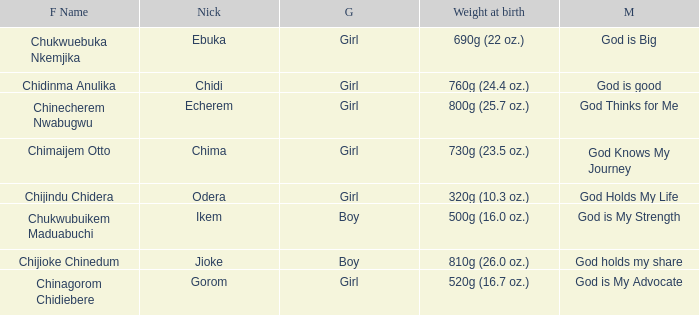Help me parse the entirety of this table. {'header': ['F Name', 'Nick', 'G', 'Weight at birth', 'M'], 'rows': [['Chukwuebuka Nkemjika', 'Ebuka', 'Girl', '690g (22 oz.)', 'God is Big'], ['Chidinma Anulika', 'Chidi', 'Girl', '760g (24.4 oz.)', 'God is good'], ['Chinecherem Nwabugwu', 'Echerem', 'Girl', '800g (25.7 oz.)', 'God Thinks for Me'], ['Chimaijem Otto', 'Chima', 'Girl', '730g (23.5 oz.)', 'God Knows My Journey'], ['Chijindu Chidera', 'Odera', 'Girl', '320g (10.3 oz.)', 'God Holds My Life'], ['Chukwubuikem Maduabuchi', 'Ikem', 'Boy', '500g (16.0 oz.)', 'God is My Strength'], ['Chijioke Chinedum', 'Jioke', 'Boy', '810g (26.0 oz.)', 'God holds my share'], ['Chinagorom Chidiebere', 'Gorom', 'Girl', '520g (16.7 oz.)', 'God is My Advocate']]} What is the nickname of the boy who weighed 810g (26.0 oz.) at birth? Jioke. 